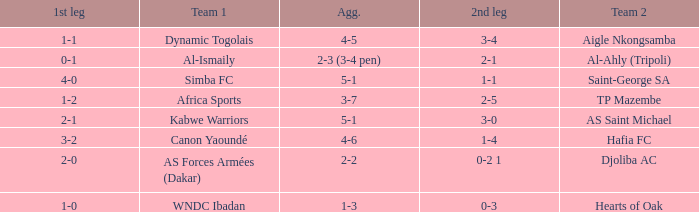What team played against Hafia FC (team 2)? Canon Yaoundé. 